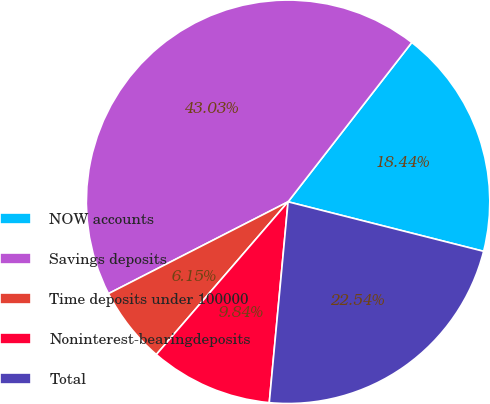<chart> <loc_0><loc_0><loc_500><loc_500><pie_chart><fcel>NOW accounts<fcel>Savings deposits<fcel>Time deposits under 100000<fcel>Noninterest-bearingdeposits<fcel>Total<nl><fcel>18.44%<fcel>43.03%<fcel>6.15%<fcel>9.84%<fcel>22.54%<nl></chart> 